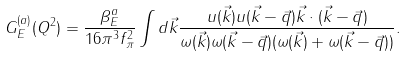<formula> <loc_0><loc_0><loc_500><loc_500>G _ { E } ^ { ( a ) } ( Q ^ { 2 } ) = \frac { \beta _ { E } ^ { a } } { 1 6 \pi ^ { 3 } f _ { \pi } ^ { 2 } } \int d \vec { k } \frac { u ( \vec { k } ) u ( \vec { k } - \vec { q } ) \vec { k } \cdot ( \vec { k } - \vec { q } ) } { \omega ( \vec { k } ) \omega ( \vec { k } - \vec { q } ) ( \omega ( \vec { k } ) + \omega ( \vec { k } - \vec { q } ) ) } .</formula> 